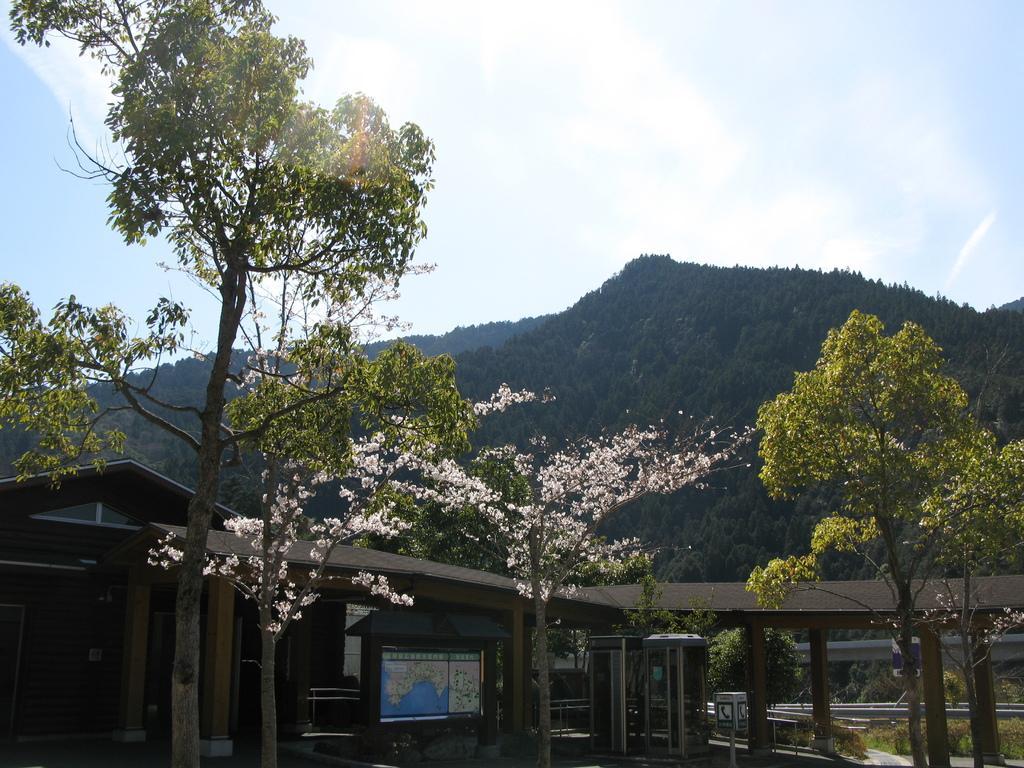In one or two sentences, can you explain what this image depicts? In this image at the bottom there are some houses, in the foreground there are some trees and in the background there are trees and mountains. At the top of the image there is sky. And in the center there are some objects present in the image. 